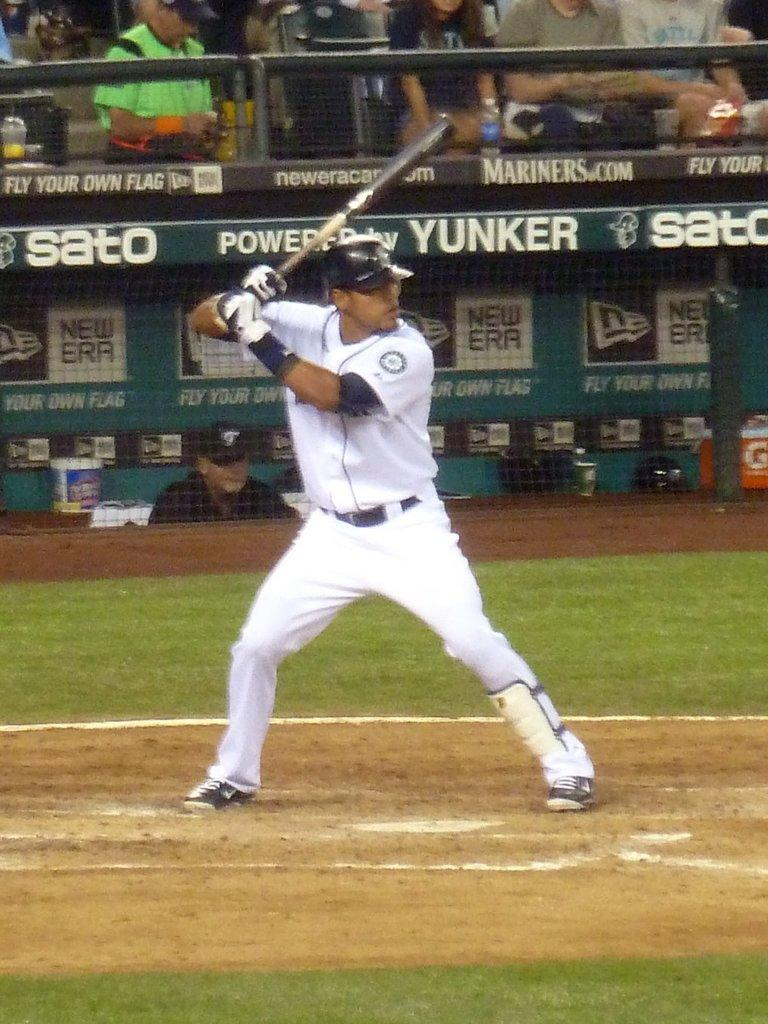<image>
Provide a brief description of the given image. A man with a baseball bat stands in front of an advert for Yunker. 